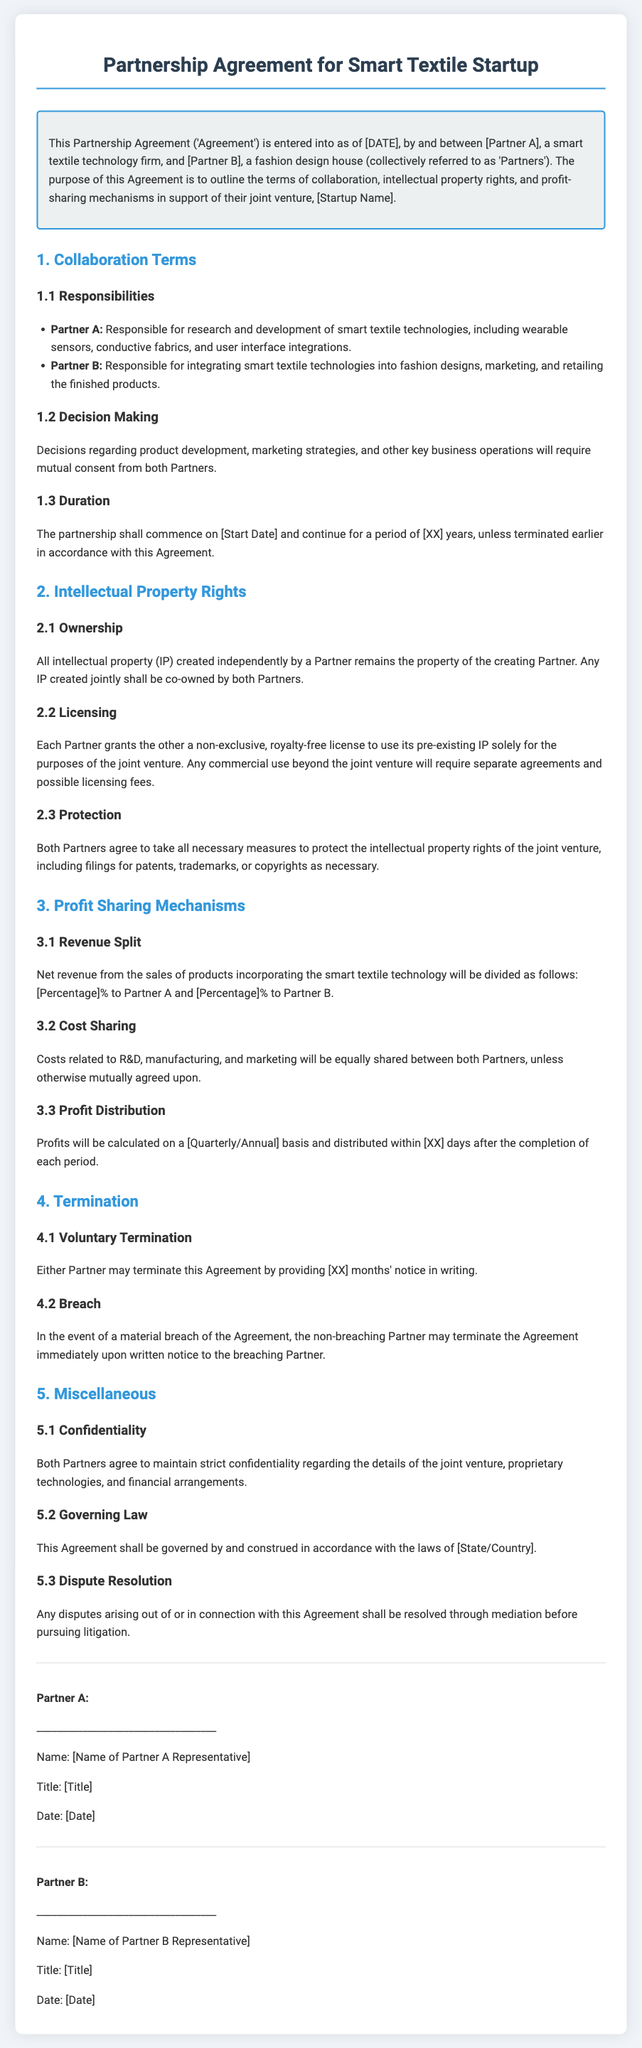What is the purpose of the Agreement? The purpose is to outline the terms of collaboration, intellectual property rights, and profit-sharing mechanisms.
Answer: Outline collaboration, IP rights, and profit-sharing Who is responsible for research and development? The agreement specifies that Partner A is responsible for research and development of smart textile technologies.
Answer: Partner A What is the duration of the partnership? The partnership shall continue for a period of [XX] years, unless terminated earlier.
Answer: [XX] years What percentage of net revenue goes to Partner B? The net revenue split is specified in the document as a percentage, but the exact number is placeholder text.
Answer: [Percentage]% What must be done before a Partner can terminate the Agreement voluntarily? Either Partner must provide a written notice with [XX] months' notice.
Answer: [XX] months What are both Partners required to maintain regarding the joint venture? Both Partners agree to maintain strict confidentiality regarding several aspects of the venture.
Answer: Confidentiality How will disputes be resolved according to the Agreement? Any disputes shall be resolved through mediation before pursuing litigation.
Answer: Mediation What type of license is granted for pre-existing IP? Each Partner grants a non-exclusive, royalty-free license to use pre-existing IP solely for the joint venture.
Answer: Non-exclusive, royalty-free What must be equally shared between both Partners? Costs related to R&D, manufacturing, and marketing will be equally shared unless agreed otherwise.
Answer: Costs 